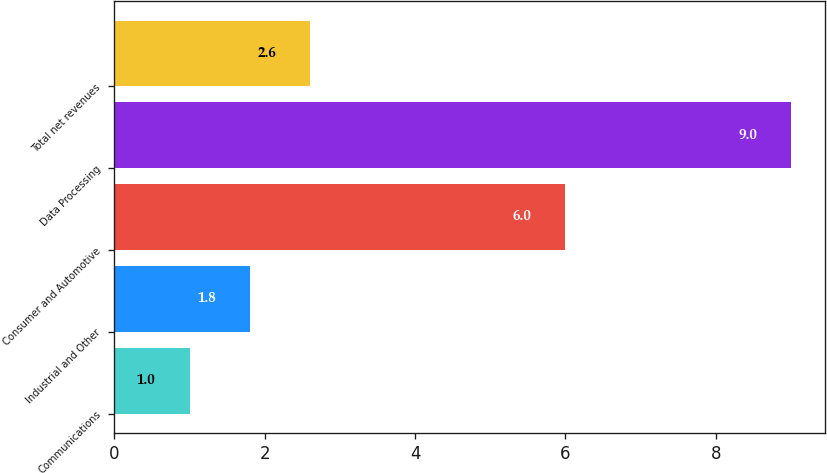<chart> <loc_0><loc_0><loc_500><loc_500><bar_chart><fcel>Communications<fcel>Industrial and Other<fcel>Consumer and Automotive<fcel>Data Processing<fcel>Total net revenues<nl><fcel>1<fcel>1.8<fcel>6<fcel>9<fcel>2.6<nl></chart> 